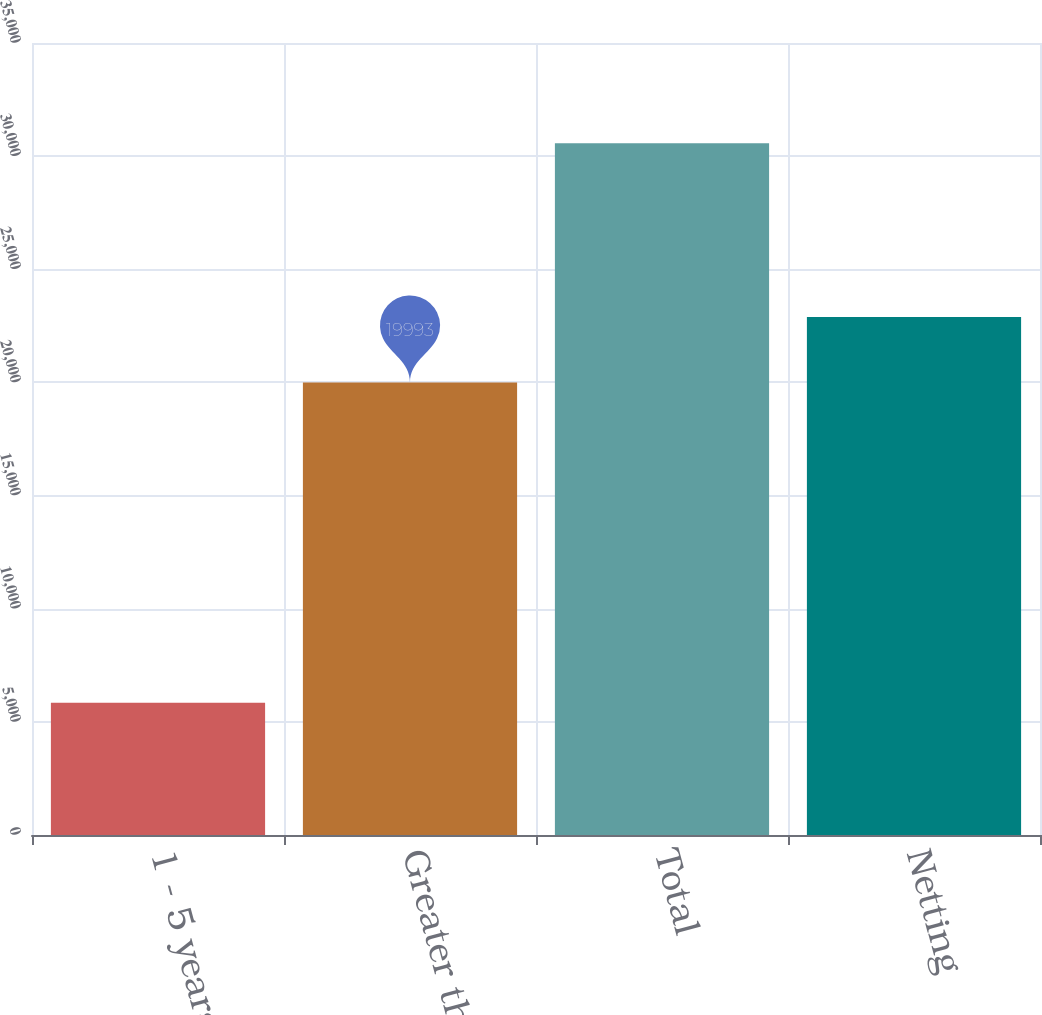Convert chart to OTSL. <chart><loc_0><loc_0><loc_500><loc_500><bar_chart><fcel>1 - 5 years<fcel>Greater than 5 years<fcel>Total<fcel>Netting<nl><fcel>5841<fcel>19993<fcel>30569<fcel>22894<nl></chart> 